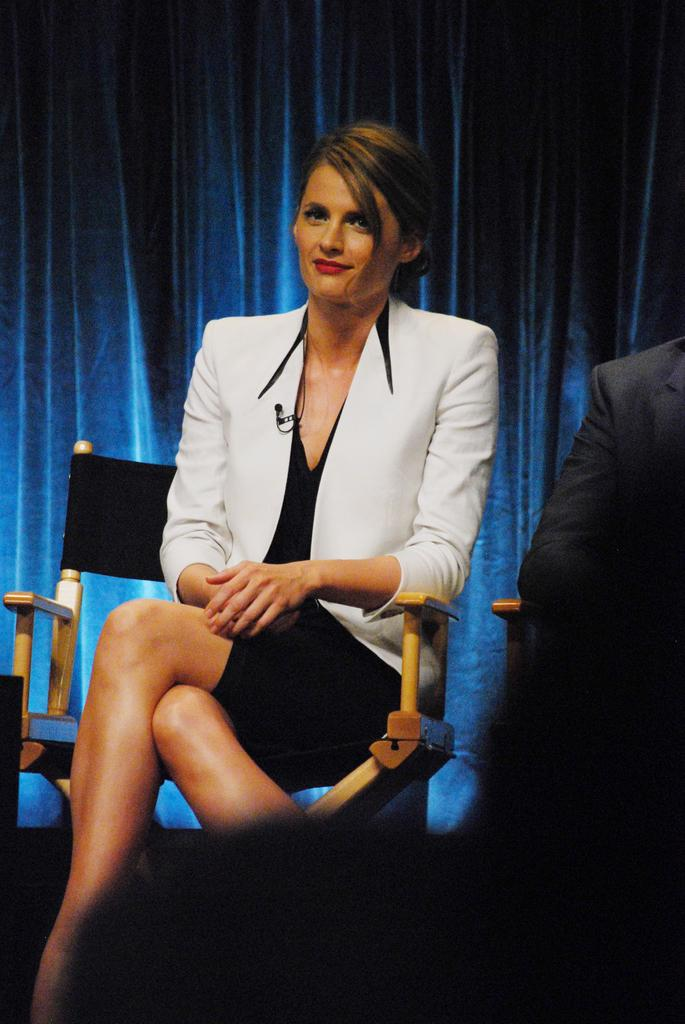How many people are present in the image? There are two people in the image. What objects are in the image that the people might sit on? There are chairs in the image. What can be seen in the background of the image? There is a curtain in the background of the image. How many spiders are crawling on the curtain in the image? There are no spiders visible in the image; only the curtain is present in the background. 